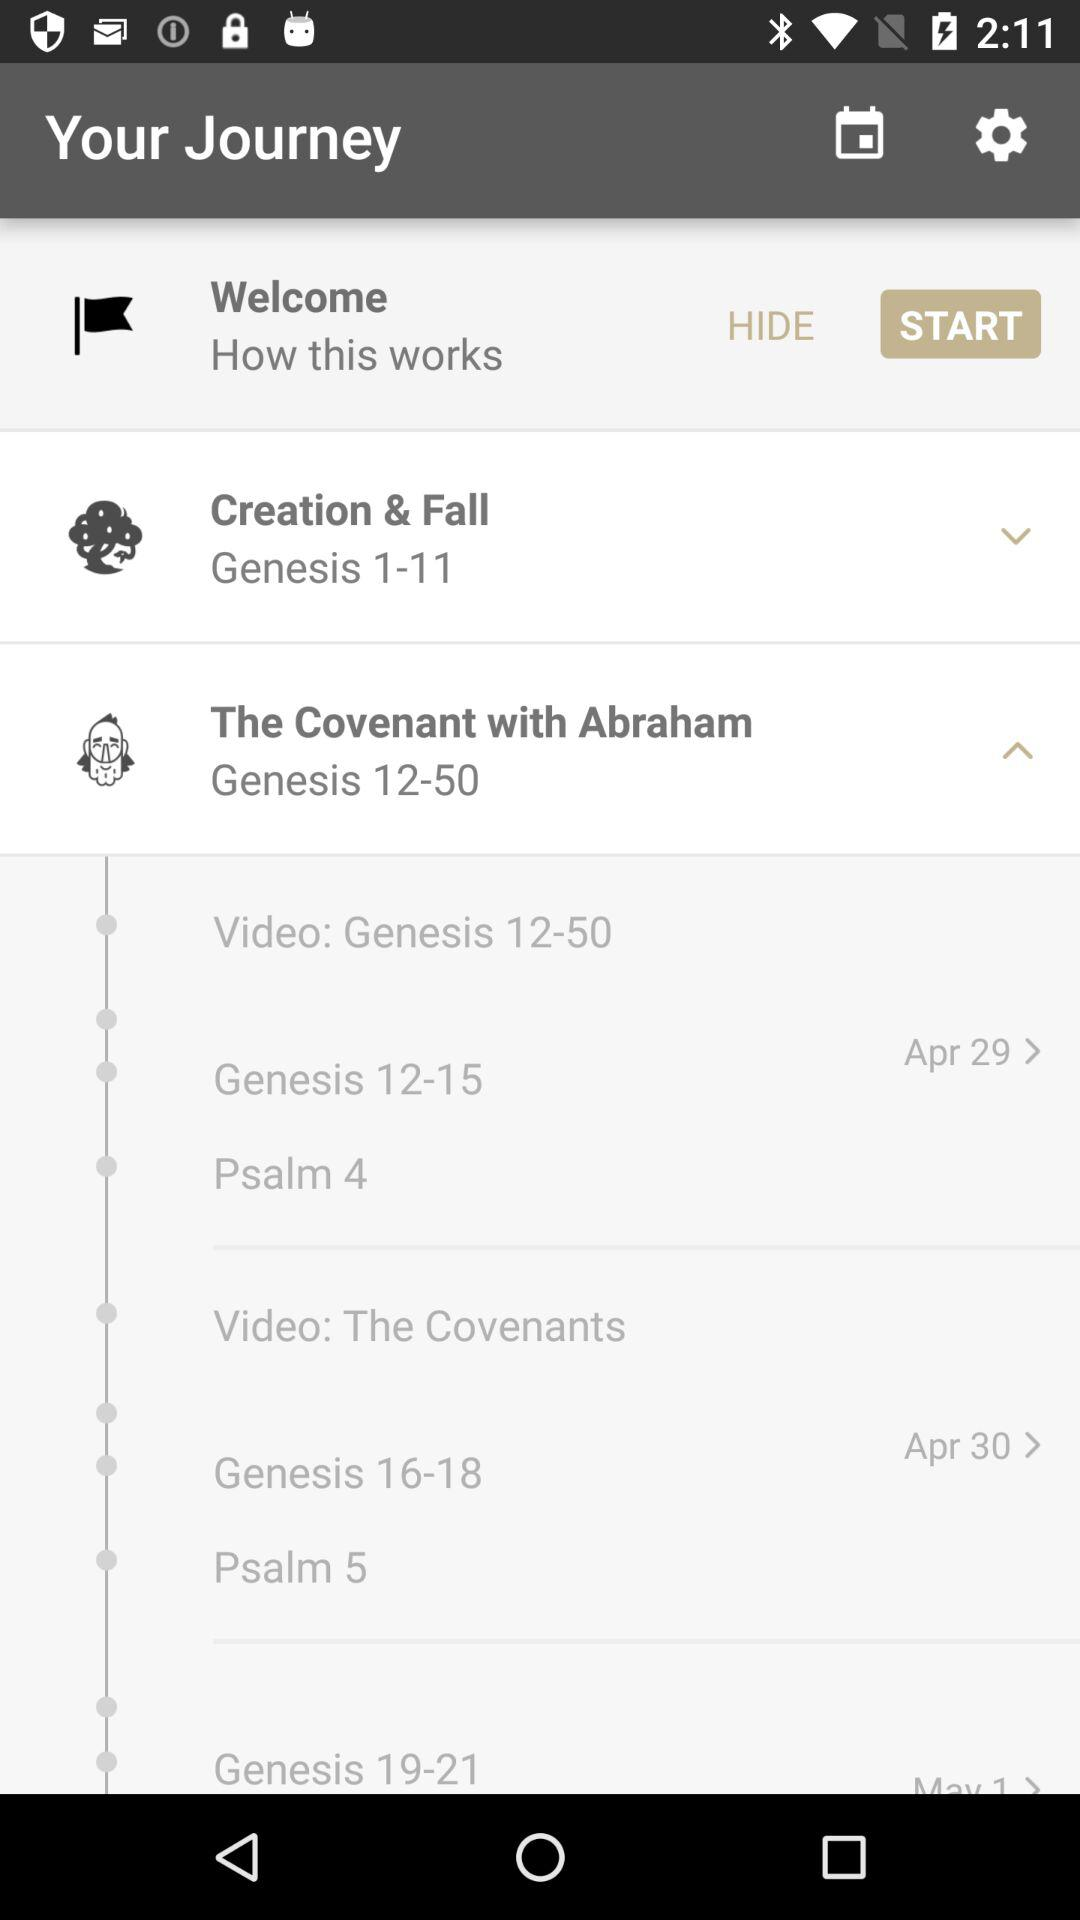Creation and fall are parts of which genesis? Creation and fall are parts of Genesis 1–11. 